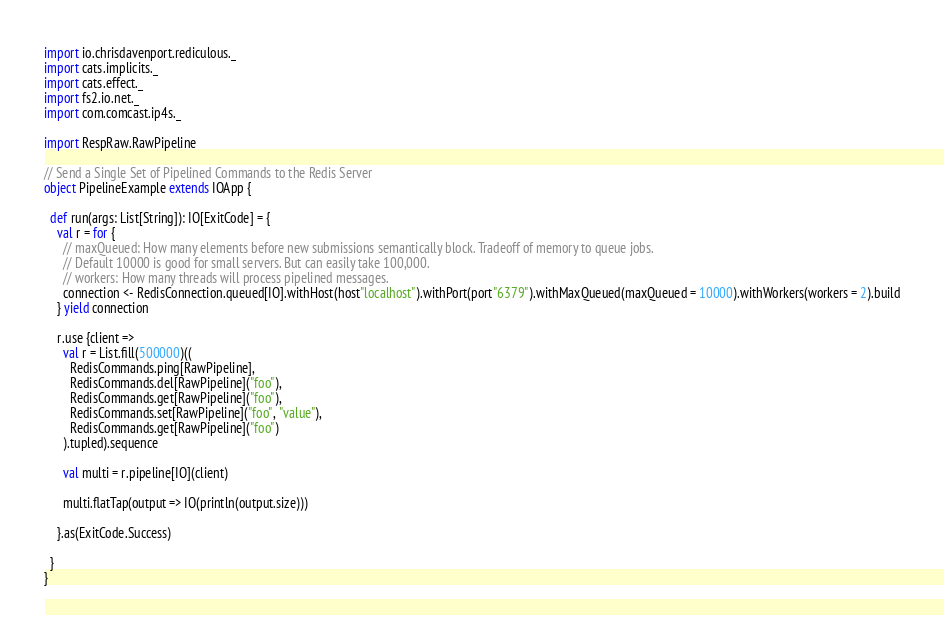Convert code to text. <code><loc_0><loc_0><loc_500><loc_500><_Scala_>import io.chrisdavenport.rediculous._
import cats.implicits._
import cats.effect._
import fs2.io.net._
import com.comcast.ip4s._

import RespRaw.RawPipeline

// Send a Single Set of Pipelined Commands to the Redis Server
object PipelineExample extends IOApp {

  def run(args: List[String]): IO[ExitCode] = {
    val r = for {
      // maxQueued: How many elements before new submissions semantically block. Tradeoff of memory to queue jobs. 
      // Default 10000 is good for small servers. But can easily take 100,000.
      // workers: How many threads will process pipelined messages.
      connection <- RedisConnection.queued[IO].withHost(host"localhost").withPort(port"6379").withMaxQueued(maxQueued = 10000).withWorkers(workers = 2).build
    } yield connection

    r.use {client =>
      val r = List.fill(500000)((
        RedisCommands.ping[RawPipeline],
        RedisCommands.del[RawPipeline]("foo"),
        RedisCommands.get[RawPipeline]("foo"),
        RedisCommands.set[RawPipeline]("foo", "value"),
        RedisCommands.get[RawPipeline]("foo")
      ).tupled).sequence

      val multi = r.pipeline[IO](client)

      multi.flatTap(output => IO(println(output.size)))

    }.as(ExitCode.Success)

  }
}</code> 